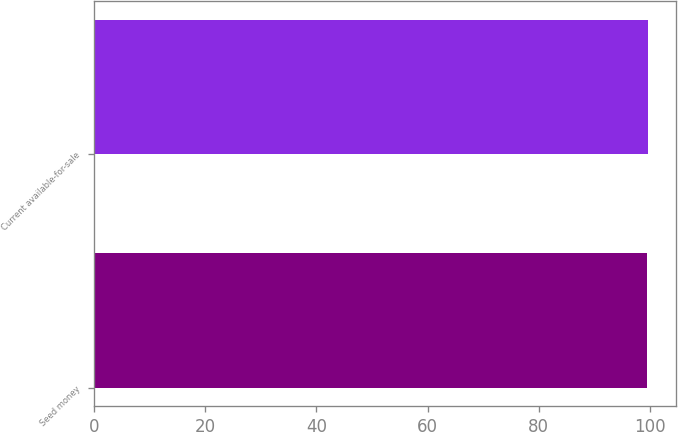<chart> <loc_0><loc_0><loc_500><loc_500><bar_chart><fcel>Seed money<fcel>Current available-for-sale<nl><fcel>99.5<fcel>99.6<nl></chart> 